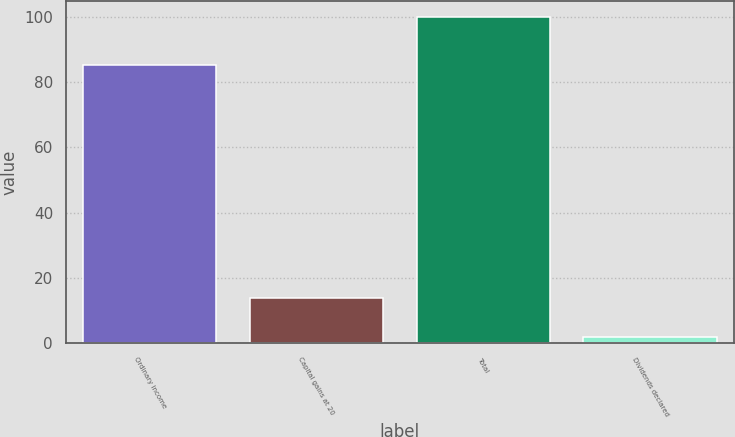Convert chart. <chart><loc_0><loc_0><loc_500><loc_500><bar_chart><fcel>Ordinary income<fcel>Capital gains at 20<fcel>Total<fcel>Dividends declared<nl><fcel>85.3<fcel>13.7<fcel>100<fcel>1.75<nl></chart> 